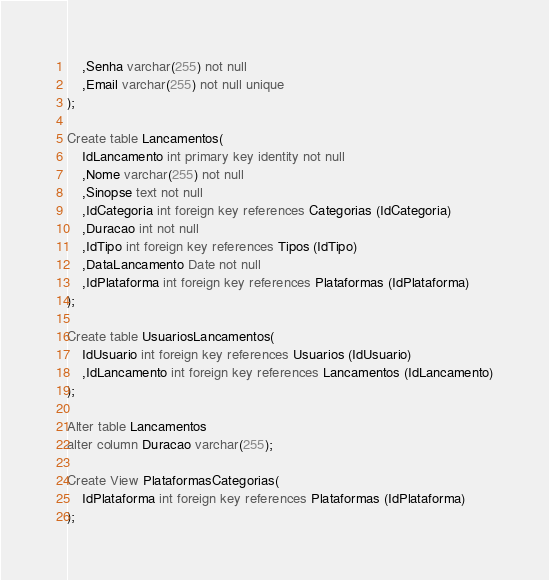<code> <loc_0><loc_0><loc_500><loc_500><_SQL_>	,Senha varchar(255) not null
	,Email varchar(255) not null unique
);

Create table Lancamentos(
	IdLancamento int primary key identity not null
	,Nome varchar(255) not null
	,Sinopse text not null
	,IdCategoria int foreign key references Categorias (IdCategoria)
	,Duracao int not null
	,IdTipo int foreign key references Tipos (IdTipo)
	,DataLancamento Date not null
	,IdPlataforma int foreign key references Plataformas (IdPlataforma)
);

Create table UsuariosLancamentos(
	IdUsuario int foreign key references Usuarios (IdUsuario)
	,IdLancamento int foreign key references Lancamentos (IdLancamento)
);

Alter table Lancamentos
alter column Duracao varchar(255);

Create View PlataformasCategorias(
	IdPlataforma int foreign key references Plataformas (IdPlataforma)
);
</code> 